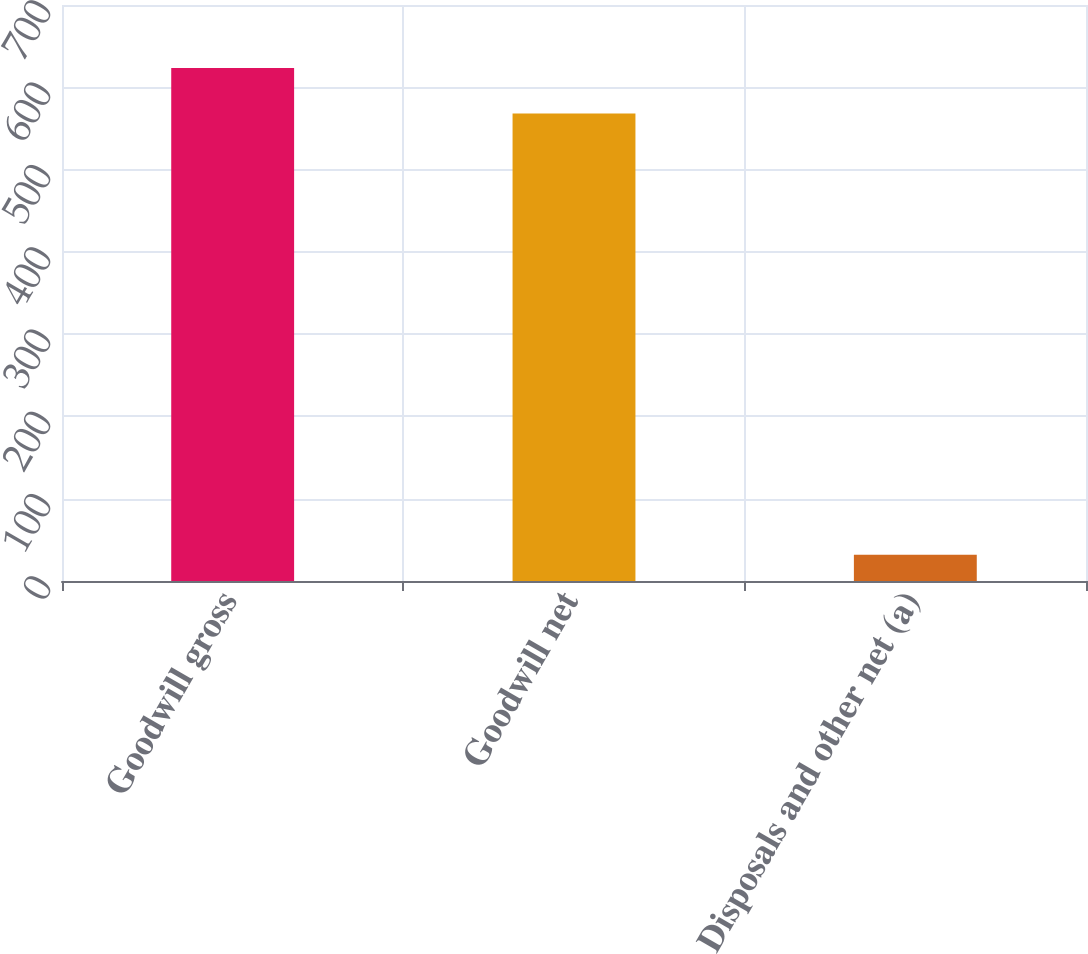Convert chart. <chart><loc_0><loc_0><loc_500><loc_500><bar_chart><fcel>Goodwill gross<fcel>Goodwill net<fcel>Disposals and other net (a)<nl><fcel>623.3<fcel>568<fcel>32<nl></chart> 